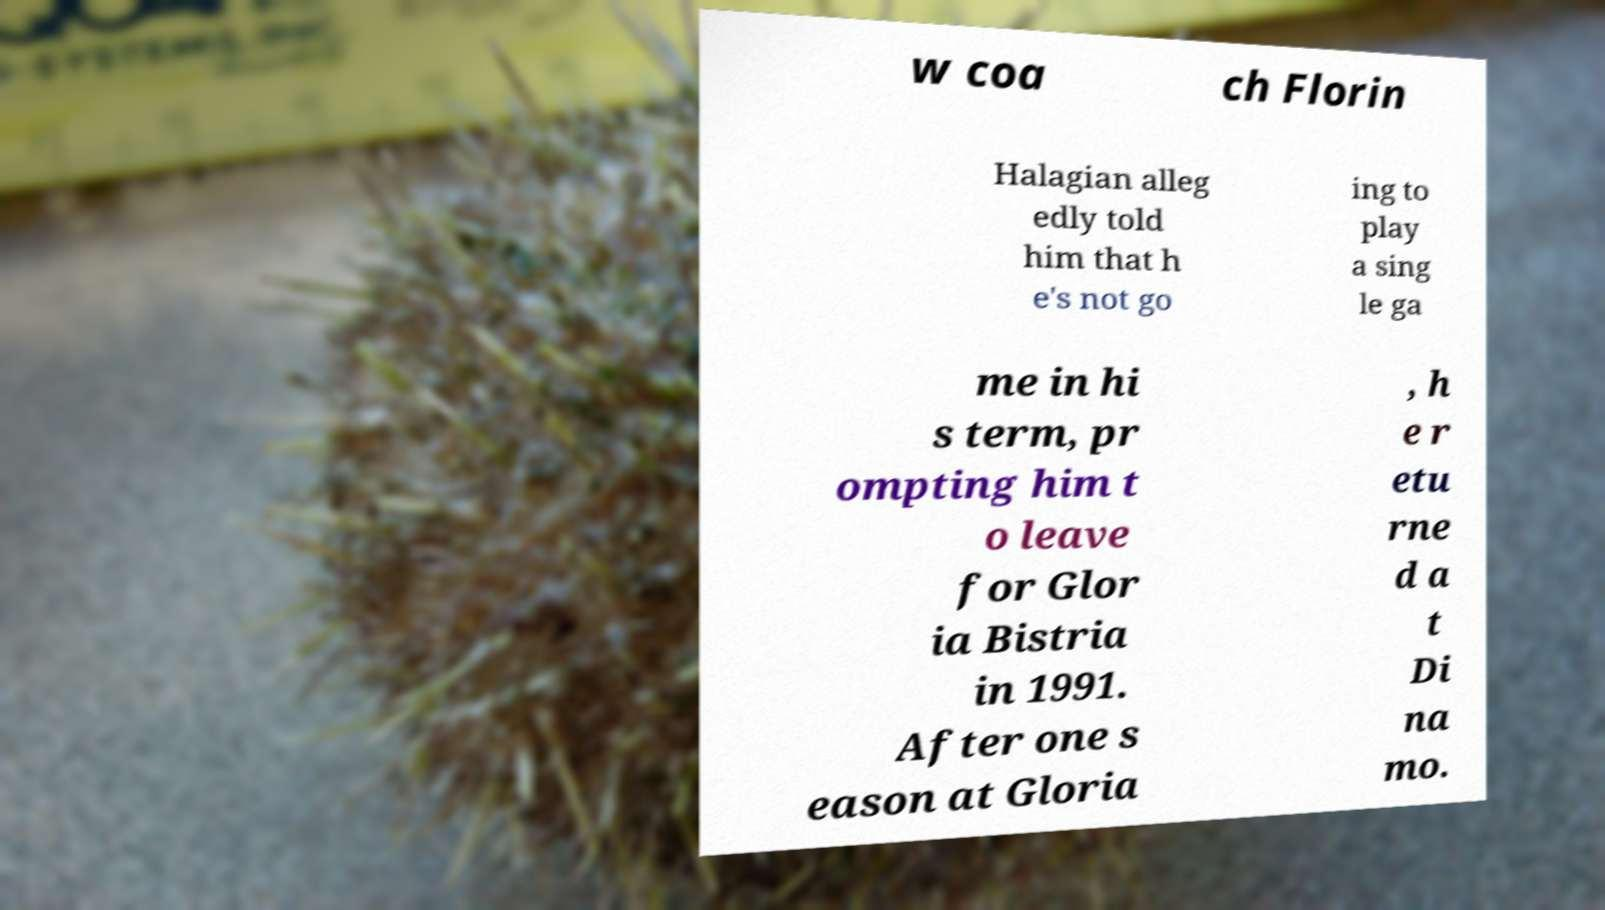There's text embedded in this image that I need extracted. Can you transcribe it verbatim? w coa ch Florin Halagian alleg edly told him that h e's not go ing to play a sing le ga me in hi s term, pr ompting him t o leave for Glor ia Bistria in 1991. After one s eason at Gloria , h e r etu rne d a t Di na mo. 